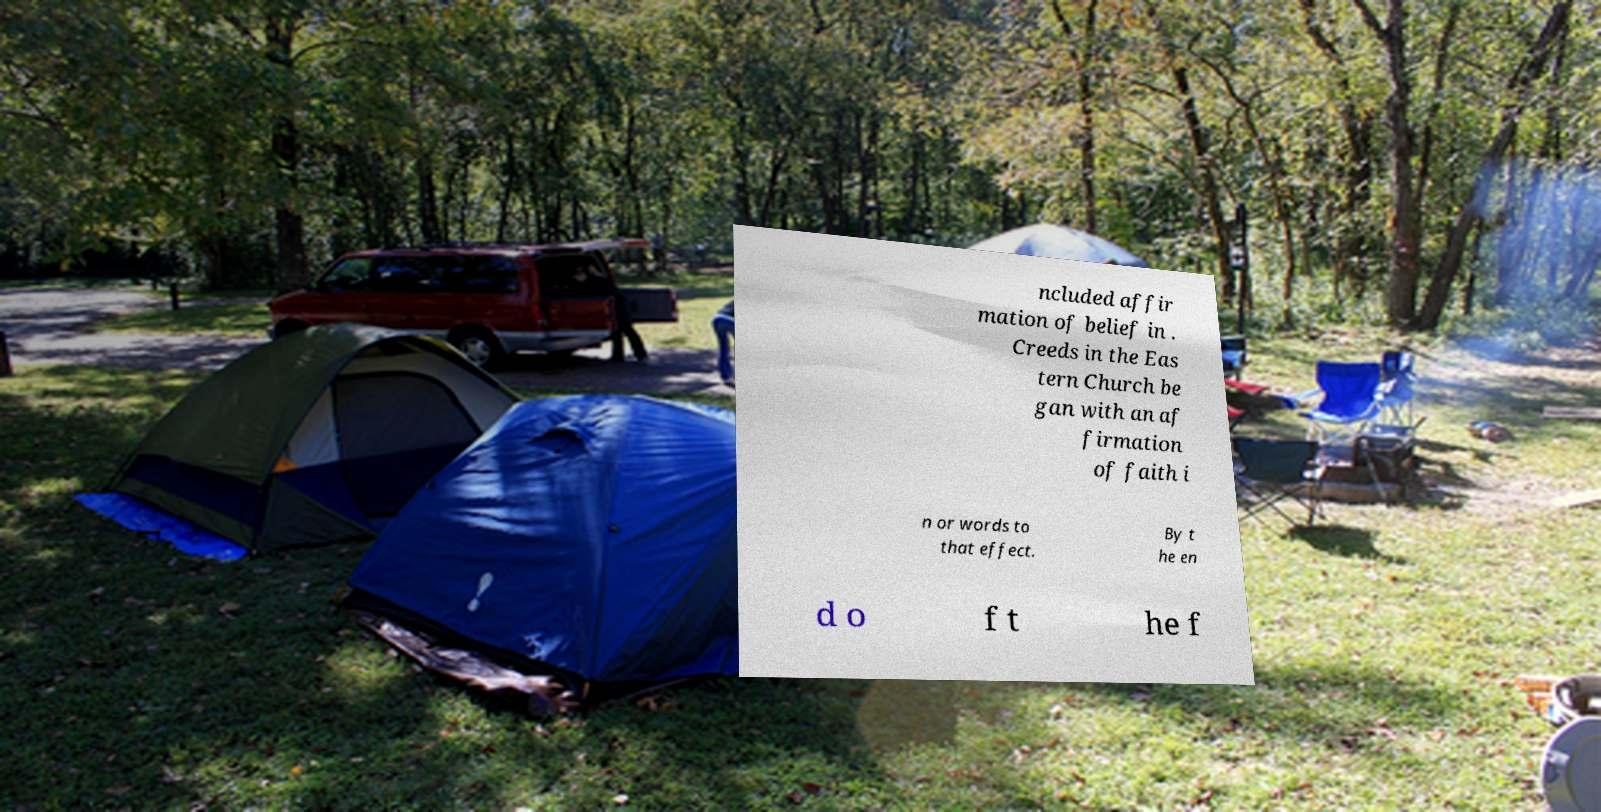Please identify and transcribe the text found in this image. ncluded affir mation of belief in . Creeds in the Eas tern Church be gan with an af firmation of faith i n or words to that effect. By t he en d o f t he f 